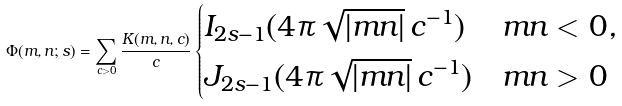<formula> <loc_0><loc_0><loc_500><loc_500>\Phi ( m , n ; s ) = \sum _ { c > 0 } \frac { K ( m , n , c ) } { c } \begin{cases} I _ { 2 s - 1 } ( 4 \pi \sqrt { | m n | } \, c ^ { - 1 } ) & m n < 0 , \\ J _ { 2 s - 1 } ( 4 \pi \sqrt { | m n | } \, c ^ { - 1 } ) & m n > 0 \end{cases}</formula> 